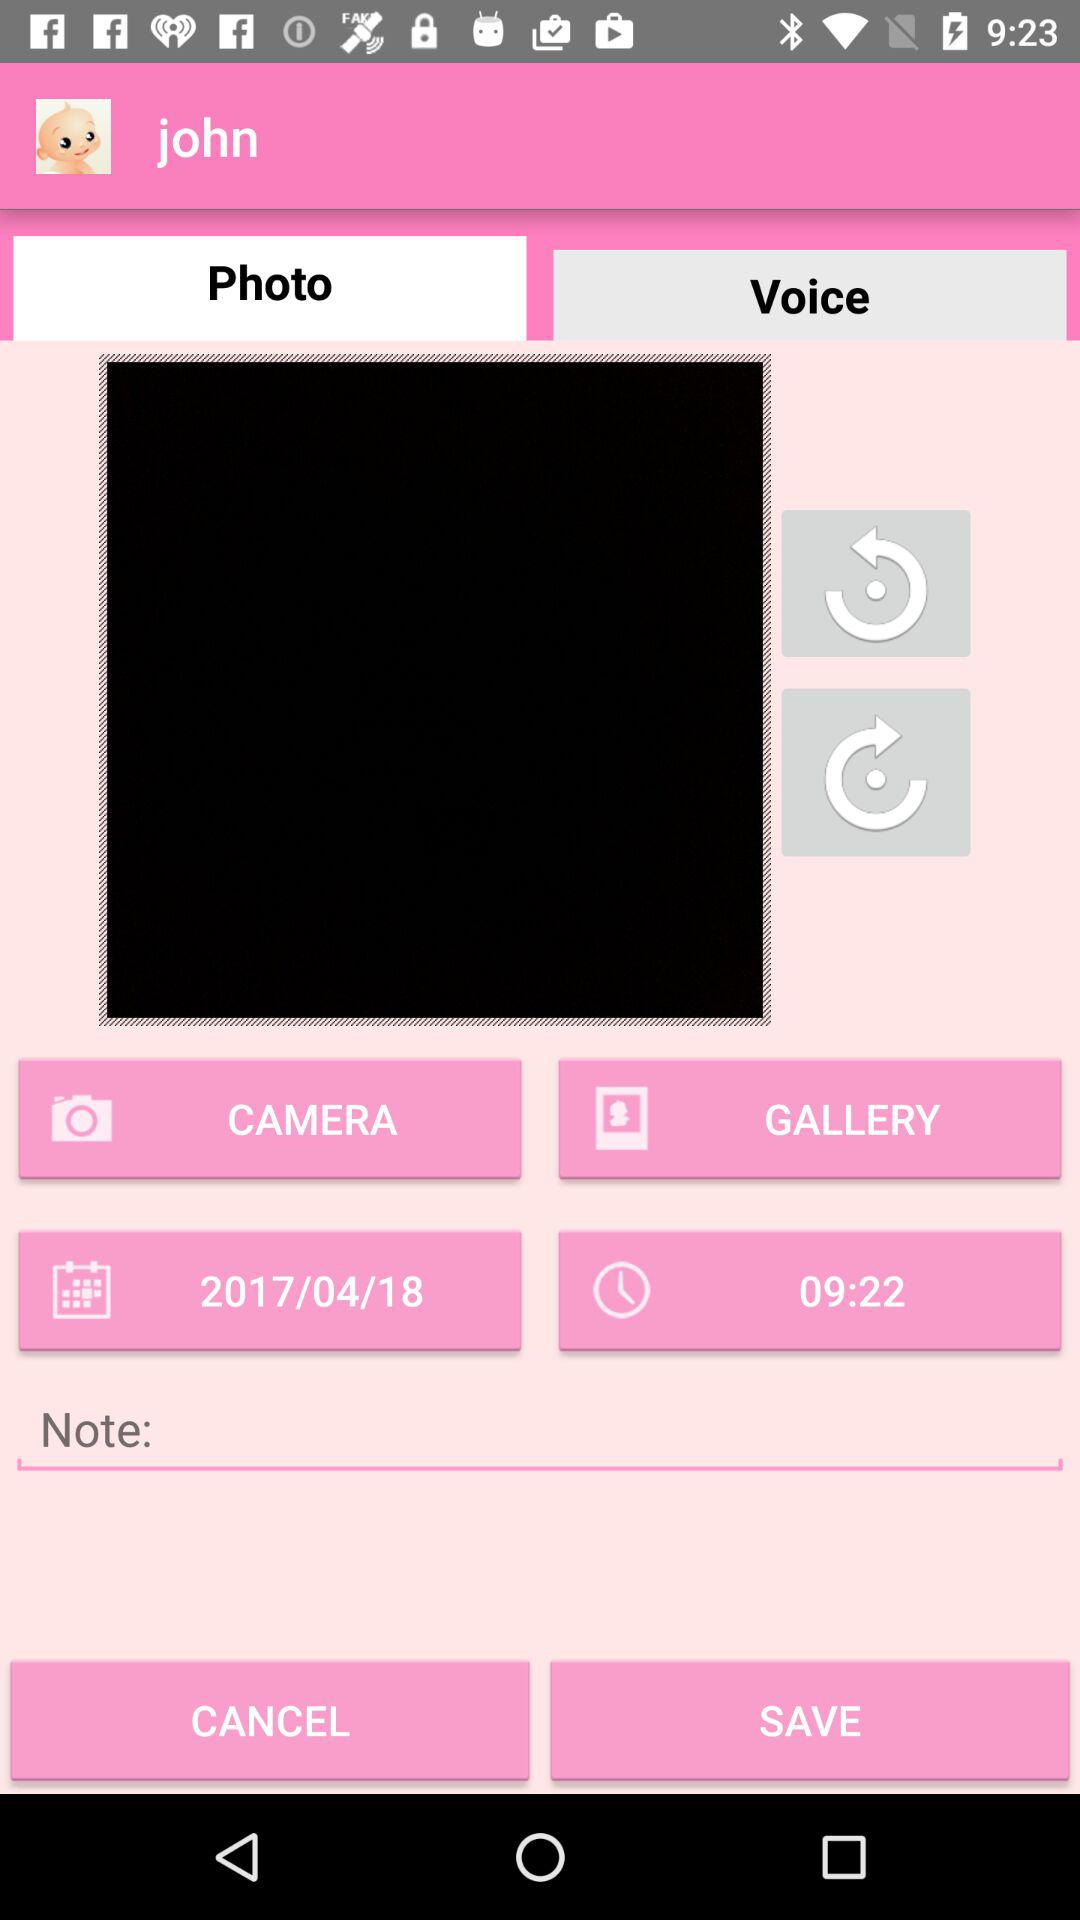What is the date? The date is April 18, 2017. 